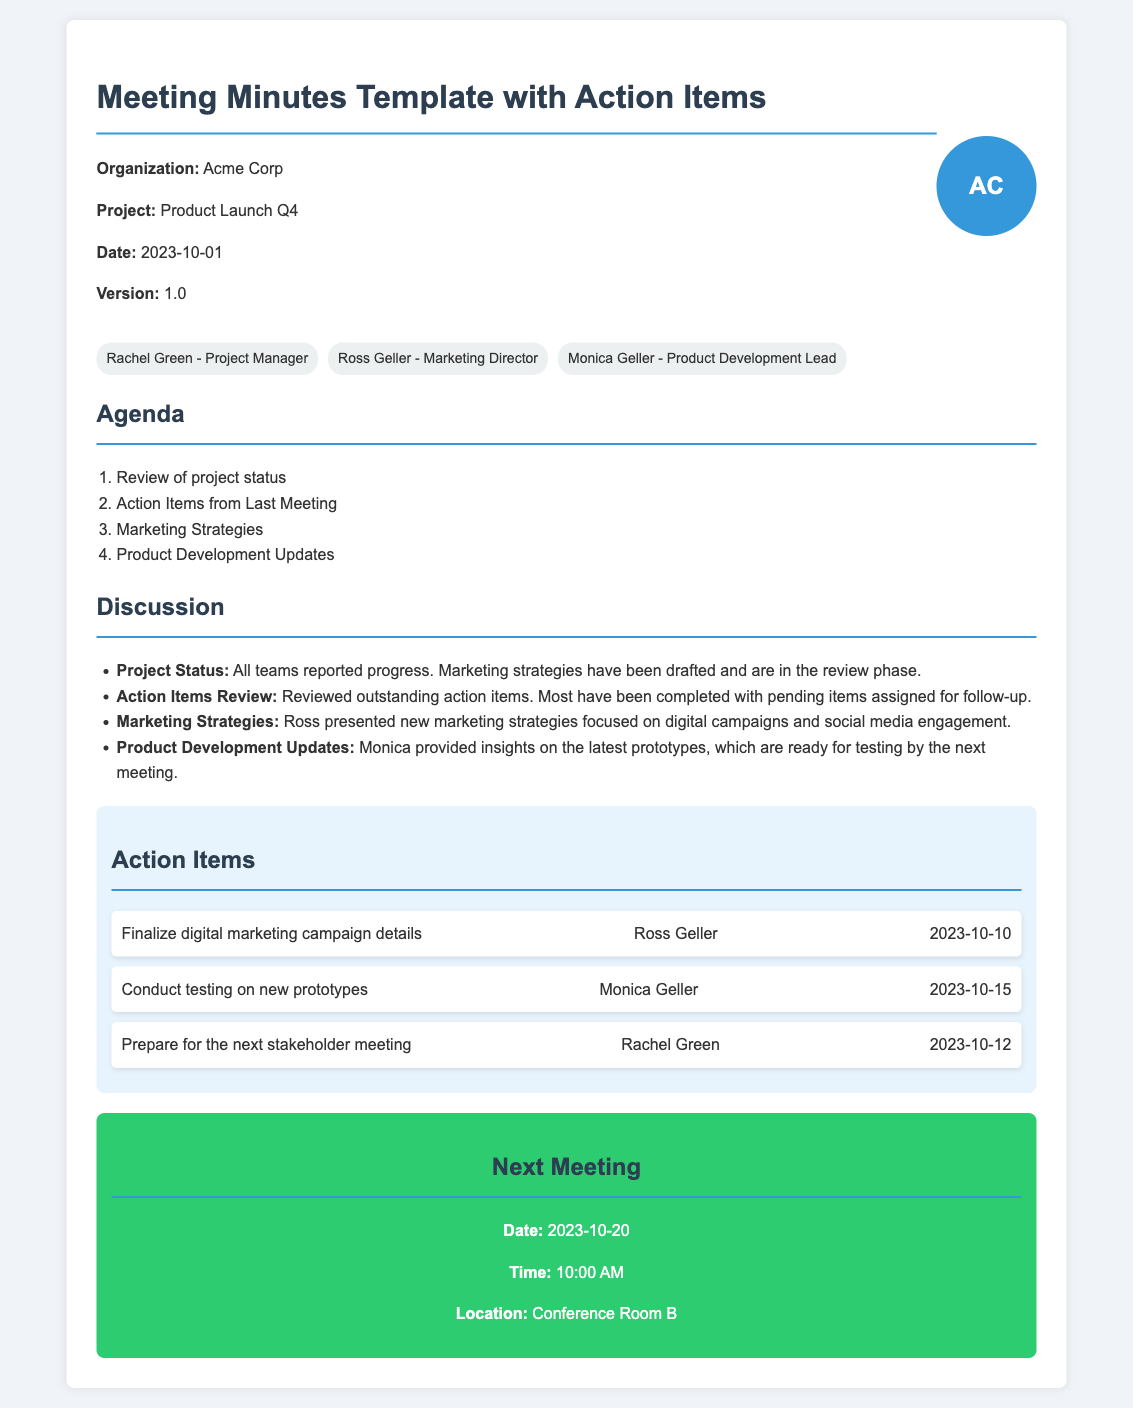What is the organization's name? The organization's name is stated in the header section of the document.
Answer: Acme Corp Who is responsible for preparing for the next stakeholder meeting? The responsible party for this action item is listed in the action items section.
Answer: Rachel Green What is the due date for finalizing the digital marketing campaign details? The due date for this action item is mentioned under the action items section.
Answer: 2023-10-10 What was one of the agenda items for the meeting? The agenda is listed as an ordered list in the document.
Answer: Review of project status Who presented the marketing strategies during the meeting? This information can be found in the discussion section where the details are summarized.
Answer: Ross Geller When is the next meeting scheduled? The next meeting date is provided in the "Next Meeting" section of the document.
Answer: 2023-10-20 What type of meeting minutes template is provided? The title at the top of the document specifies the type of template.
Answer: Meeting Minutes Template with Action Items 